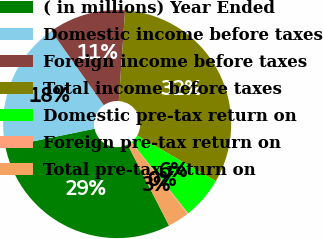Convert chart to OTSL. <chart><loc_0><loc_0><loc_500><loc_500><pie_chart><fcel>( in millions) Year Ended<fcel>Domestic income before taxes<fcel>Foreign income before taxes<fcel>Total income before taxes<fcel>Domestic pre-tax return on<fcel>Foreign pre-tax return on<fcel>Total pre-tax return on<nl><fcel>29.29%<fcel>18.43%<fcel>10.91%<fcel>32.22%<fcel>5.97%<fcel>0.13%<fcel>3.05%<nl></chart> 